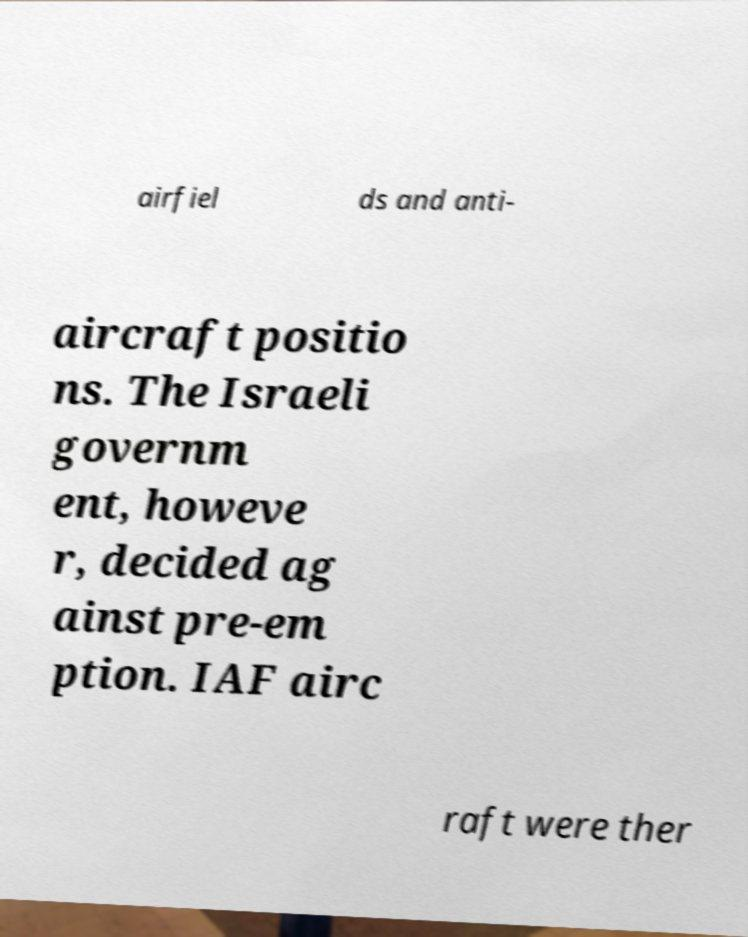Please read and relay the text visible in this image. What does it say? airfiel ds and anti- aircraft positio ns. The Israeli governm ent, howeve r, decided ag ainst pre-em ption. IAF airc raft were ther 